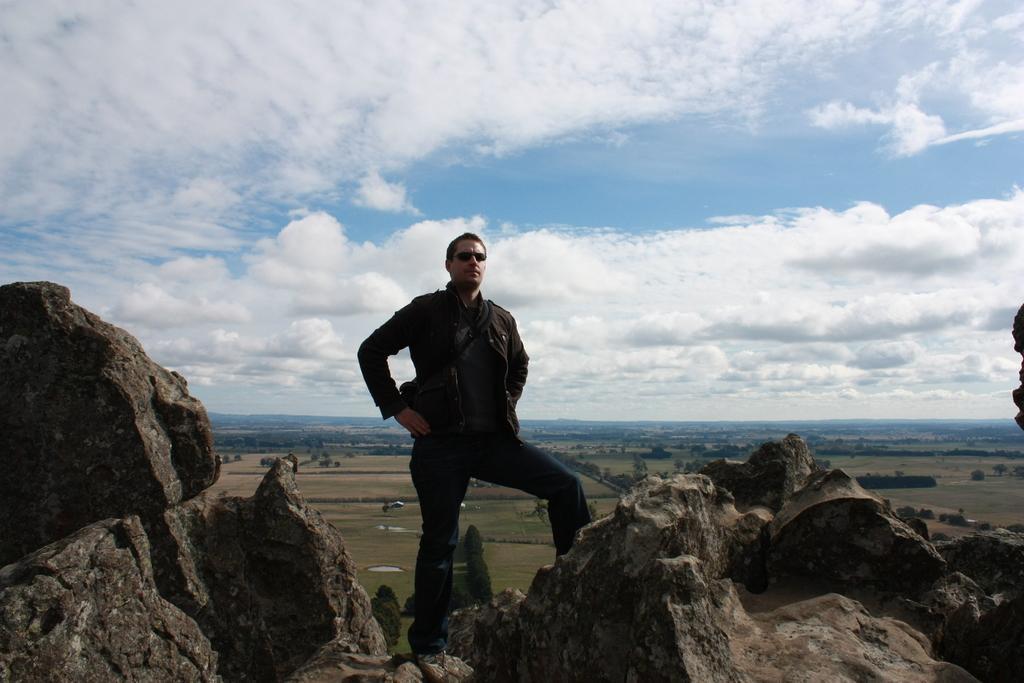Can you describe this image briefly? As we can see in the image there are rocks and a person standing in the front. In the background there are trees and sky. At the top there is sky and clouds. 